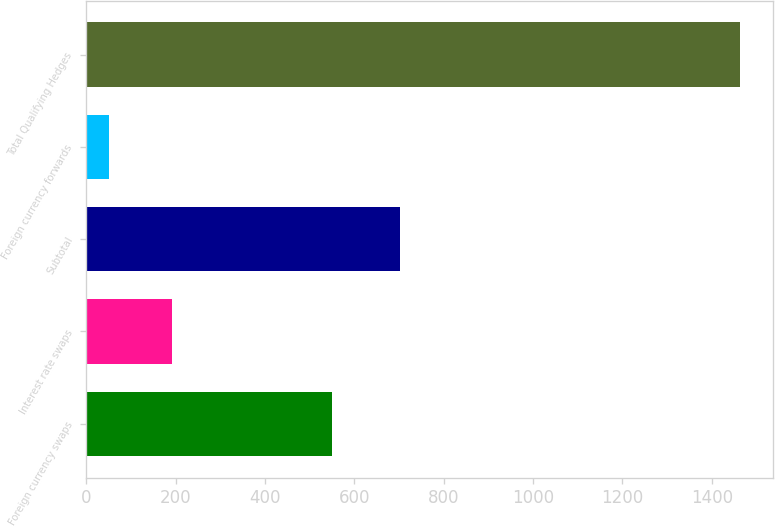Convert chart to OTSL. <chart><loc_0><loc_0><loc_500><loc_500><bar_chart><fcel>Foreign currency swaps<fcel>Interest rate swaps<fcel>Subtotal<fcel>Foreign currency forwards<fcel>Total Qualifying Hedges<nl><fcel>550<fcel>191.3<fcel>703<fcel>50<fcel>1463<nl></chart> 